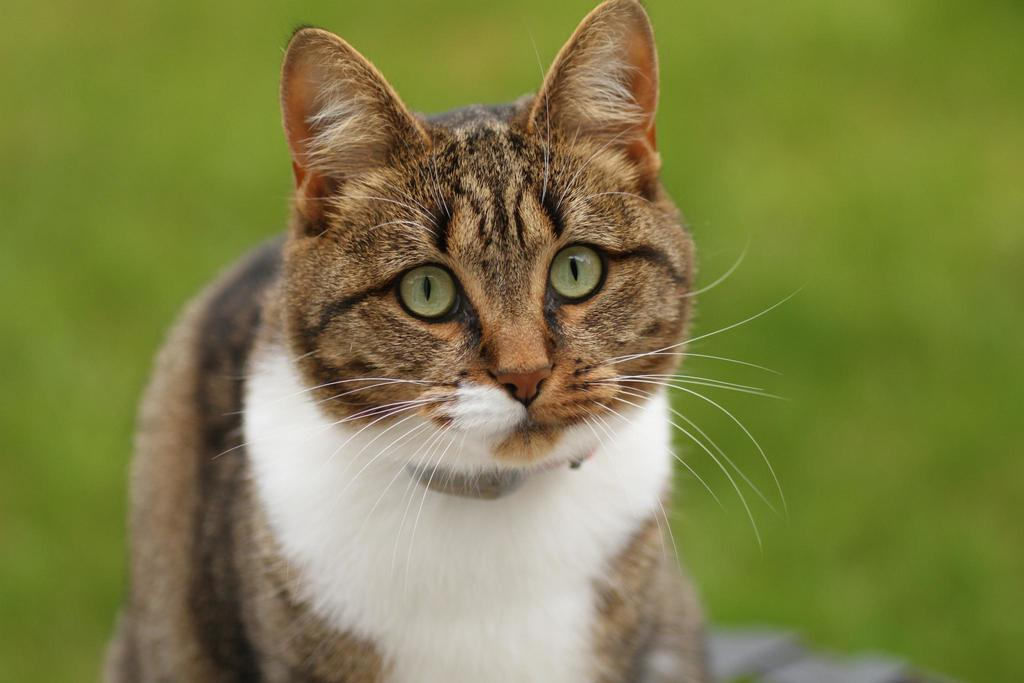What type of animal is in the image? There is a cat in the image. Can you describe the background of the image? The background of the image is blurry. What type of jeans is the cat wearing in the image? There are no jeans present in the image, as the subject is a cat and animals do not wear clothing. 